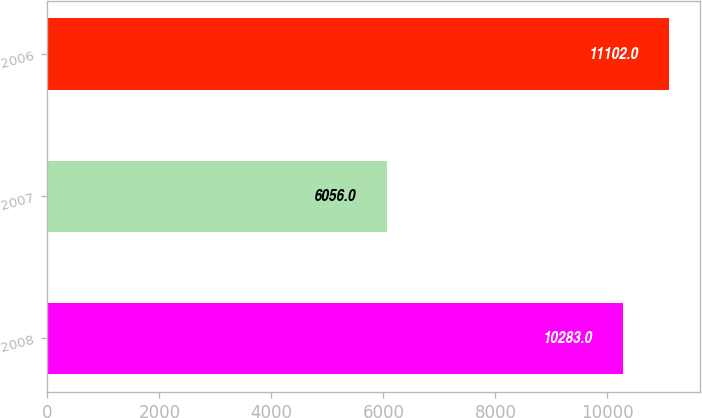Convert chart to OTSL. <chart><loc_0><loc_0><loc_500><loc_500><bar_chart><fcel>2008<fcel>2007<fcel>2006<nl><fcel>10283<fcel>6056<fcel>11102<nl></chart> 